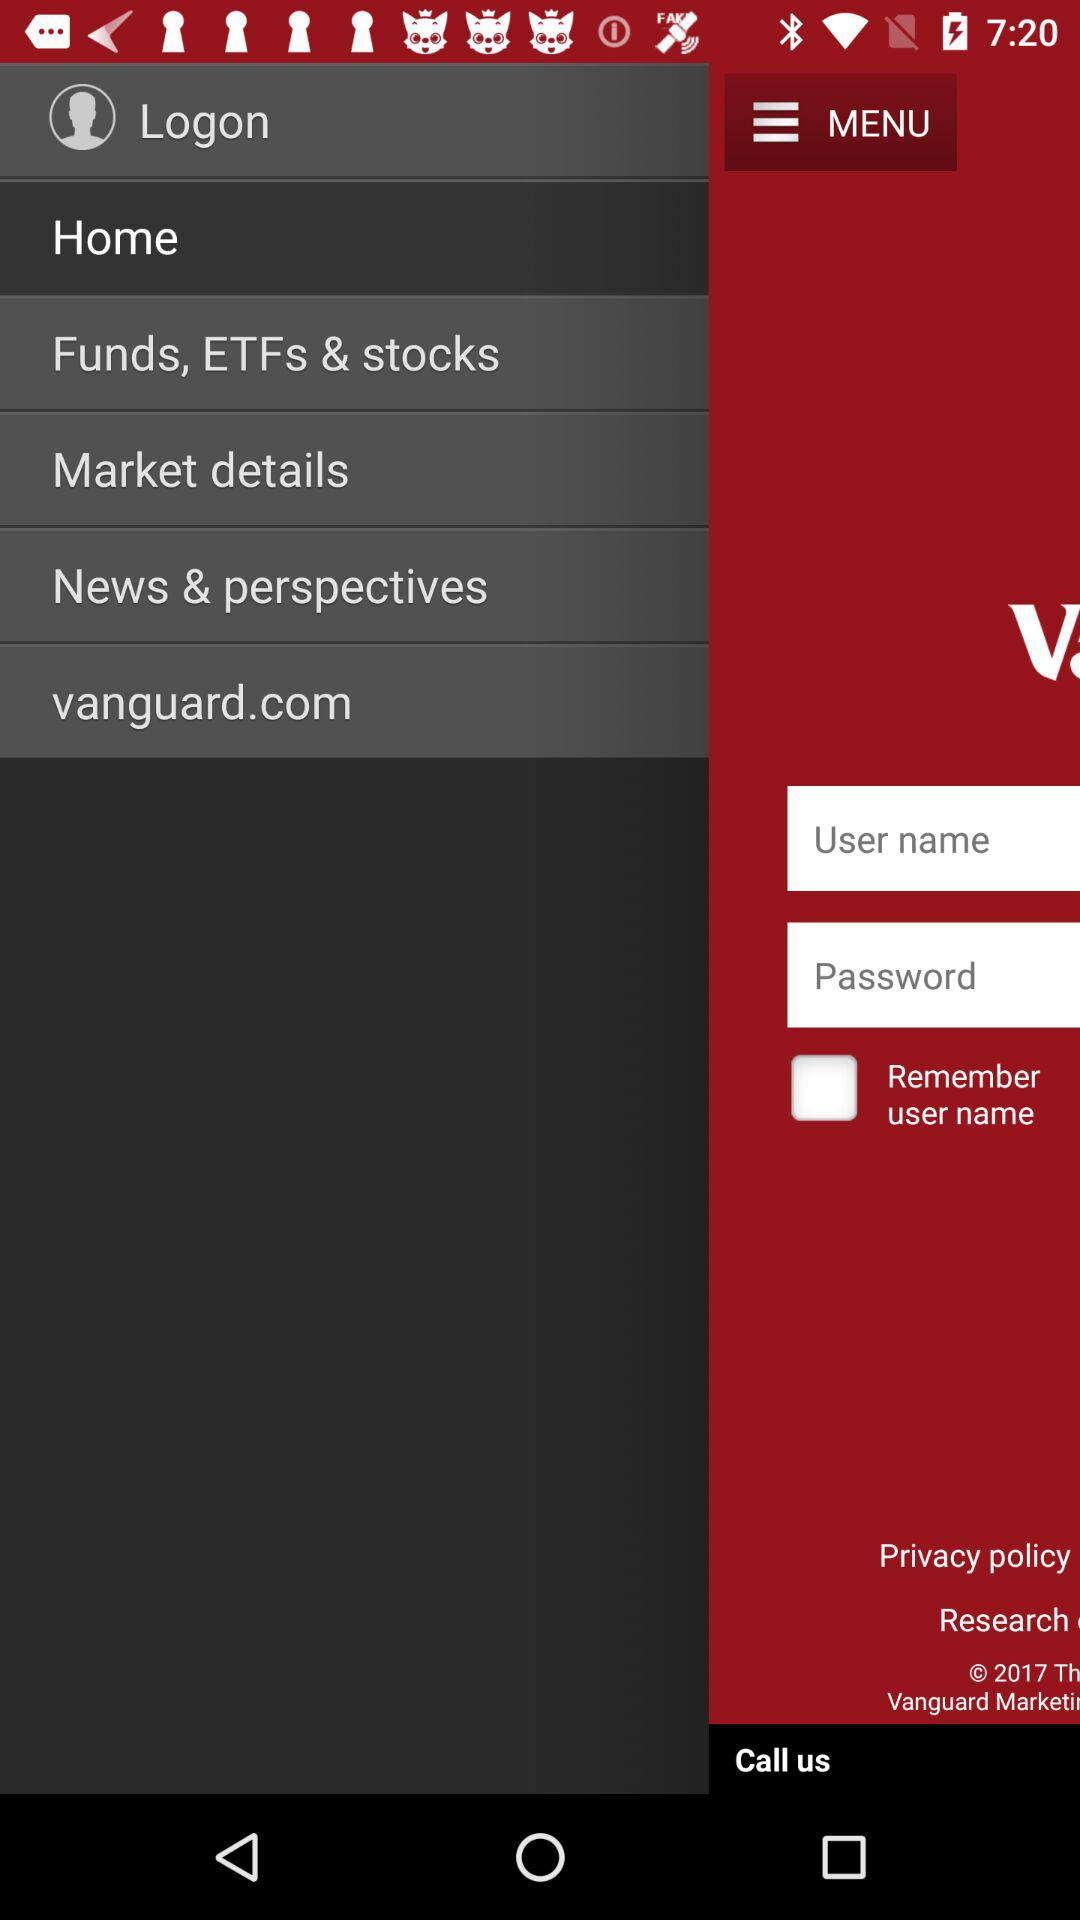How many text inputs are on the screen?
Answer the question using a single word or phrase. 2 